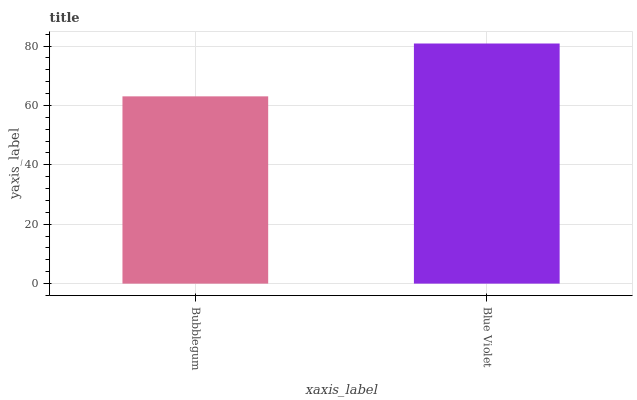Is Bubblegum the minimum?
Answer yes or no. Yes. Is Blue Violet the maximum?
Answer yes or no. Yes. Is Blue Violet the minimum?
Answer yes or no. No. Is Blue Violet greater than Bubblegum?
Answer yes or no. Yes. Is Bubblegum less than Blue Violet?
Answer yes or no. Yes. Is Bubblegum greater than Blue Violet?
Answer yes or no. No. Is Blue Violet less than Bubblegum?
Answer yes or no. No. Is Blue Violet the high median?
Answer yes or no. Yes. Is Bubblegum the low median?
Answer yes or no. Yes. Is Bubblegum the high median?
Answer yes or no. No. Is Blue Violet the low median?
Answer yes or no. No. 